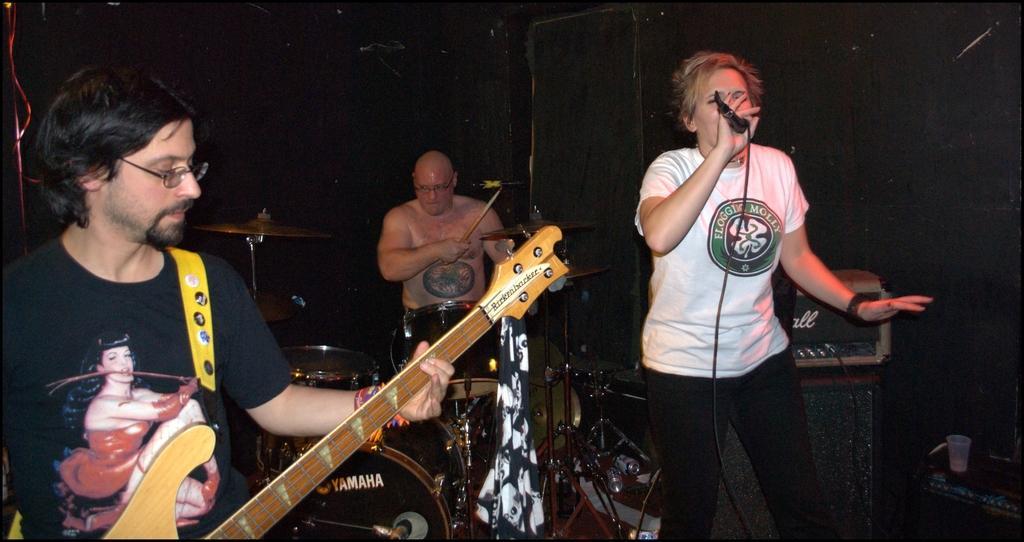In one or two sentences, can you explain what this image depicts? In the image there are three people playing their musical instruments. On right side there is a man who is holding microphone and singing. On left side there is a man who is holding guitar and playing it in middle there is a man who is playing his musical instrument. 